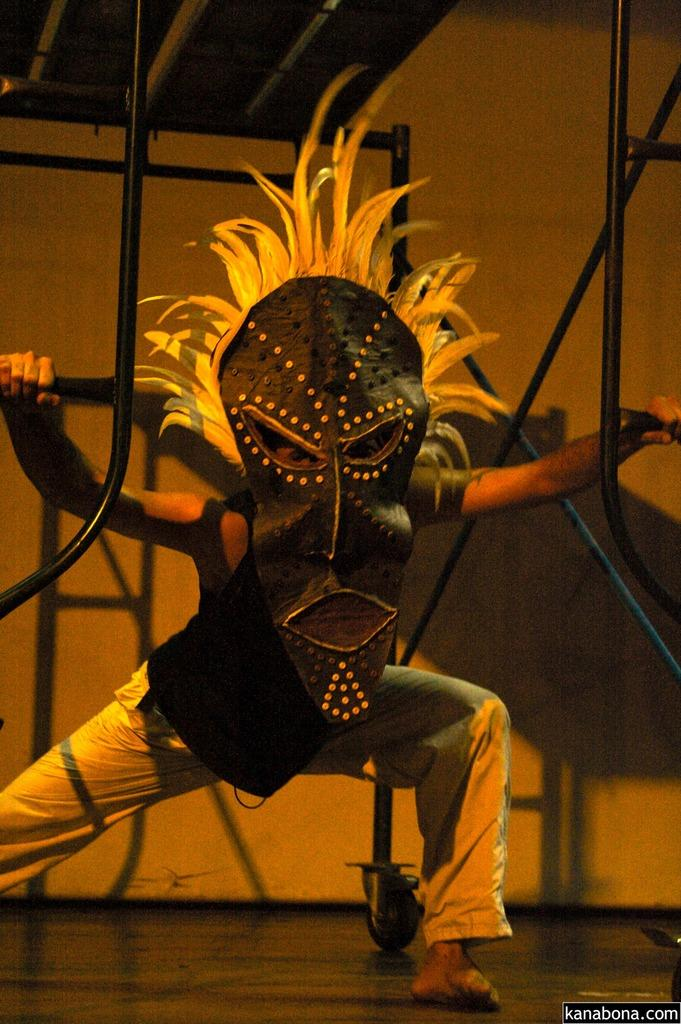What is the person in the image wearing on their face? The person in the image is wearing a mask. What can be seen behind the person in the image? There is a wall in the background of the image. What objects are present in the image that resemble long, thin sticks? There are rods in the image. What surface is visible at the bottom of the image? There is a floor at the bottom of the image. How many houses can be seen in the image? There are no houses visible in the image. What type of whip is being used by the person in the image? There is no whip visible in the image. 